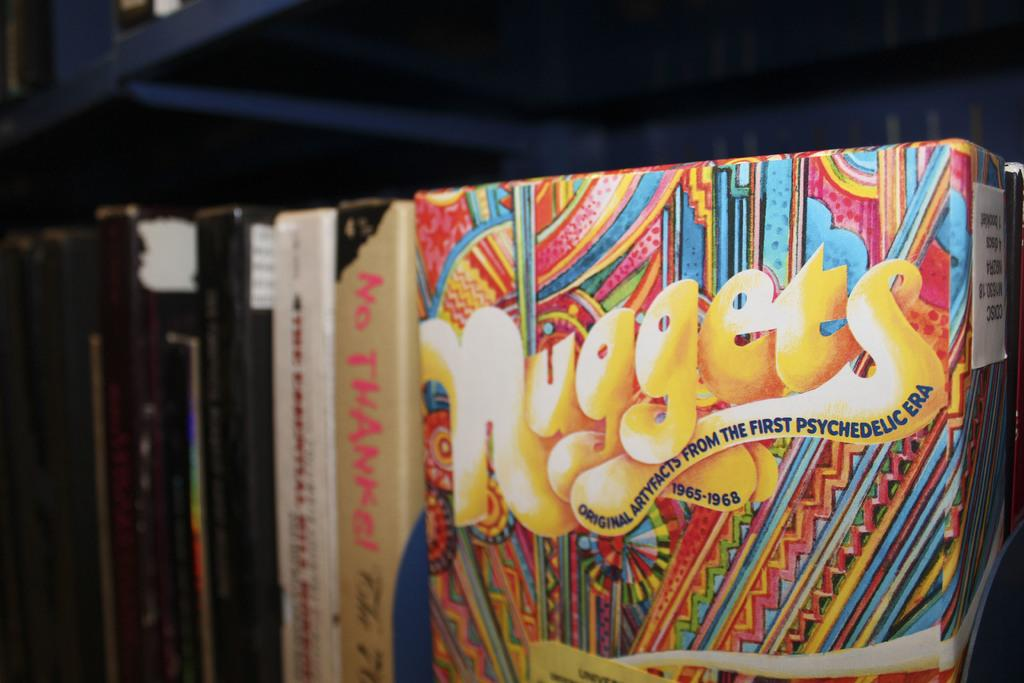<image>
Present a compact description of the photo's key features. A colorful book cover with the title of Nuggets. 